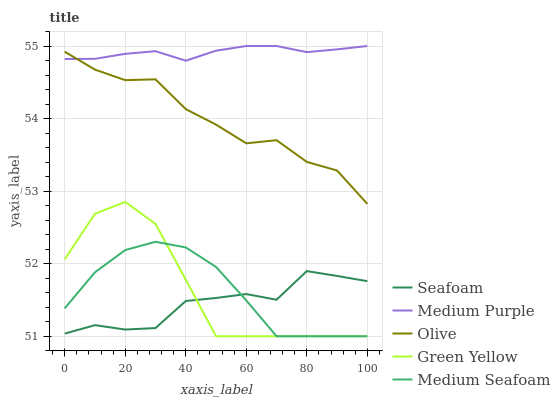Does Olive have the minimum area under the curve?
Answer yes or no. No. Does Olive have the maximum area under the curve?
Answer yes or no. No. Is Olive the smoothest?
Answer yes or no. No. Is Olive the roughest?
Answer yes or no. No. Does Olive have the lowest value?
Answer yes or no. No. Does Olive have the highest value?
Answer yes or no. No. Is Seafoam less than Olive?
Answer yes or no. Yes. Is Olive greater than Medium Seafoam?
Answer yes or no. Yes. Does Seafoam intersect Olive?
Answer yes or no. No. 